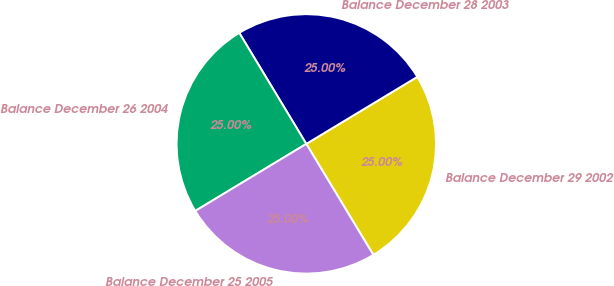Convert chart. <chart><loc_0><loc_0><loc_500><loc_500><pie_chart><fcel>Balance December 29 2002<fcel>Balance December 28 2003<fcel>Balance December 26 2004<fcel>Balance December 25 2005<nl><fcel>25.0%<fcel>25.0%<fcel>25.0%<fcel>25.0%<nl></chart> 